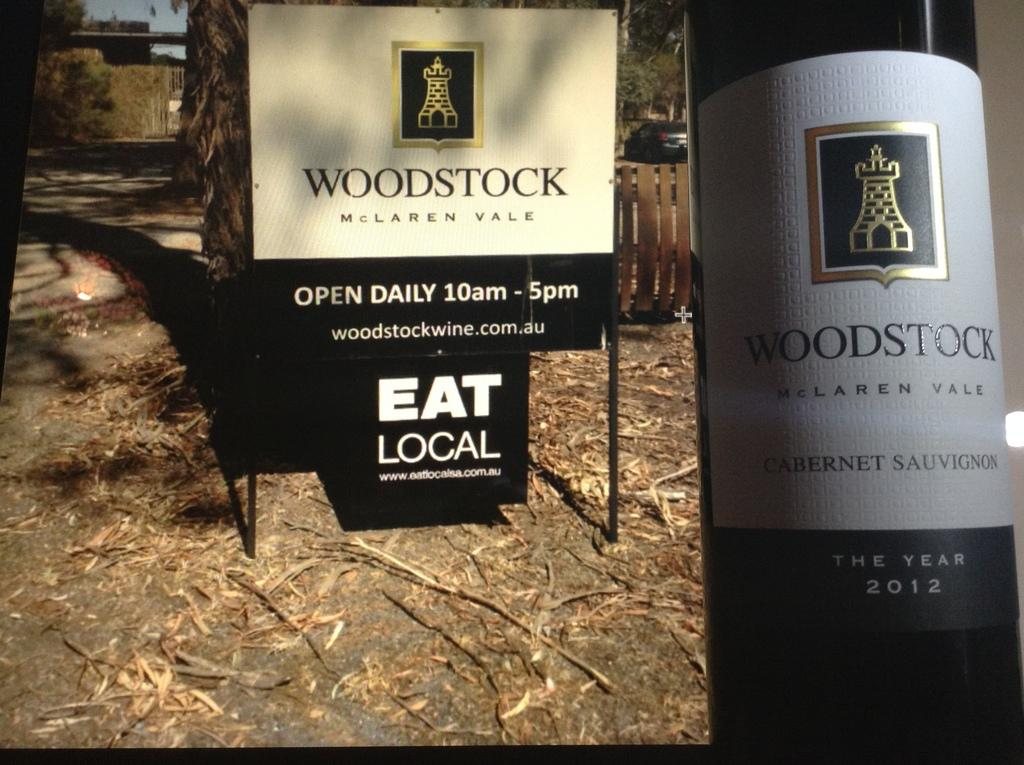<image>
Provide a brief description of the given image. A sign for Woodstock winery next to an image of their Woodstock wine bottle. 